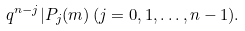Convert formula to latex. <formula><loc_0><loc_0><loc_500><loc_500>q ^ { n - j } | P _ { j } ( m ) \, ( j = 0 , 1 , \dots , n - 1 ) .</formula> 